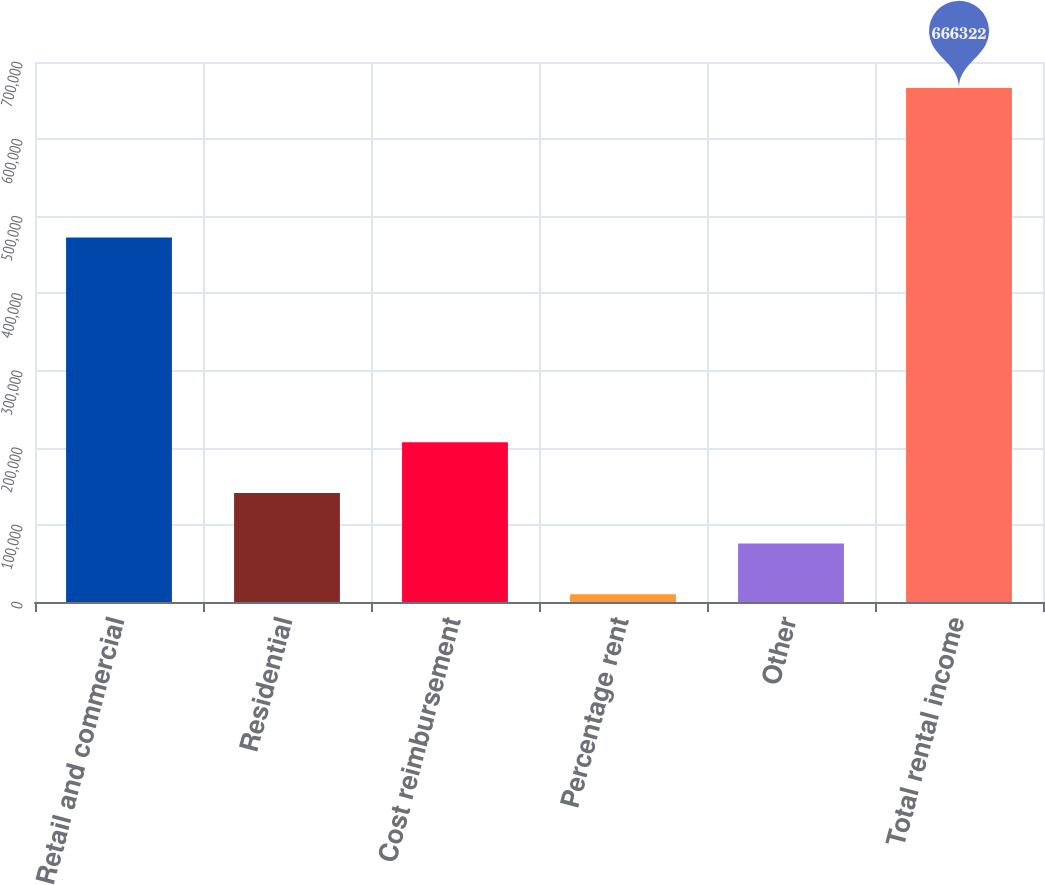Convert chart to OTSL. <chart><loc_0><loc_0><loc_500><loc_500><bar_chart><fcel>Retail and commercial<fcel>Residential<fcel>Cost reimbursement<fcel>Percentage rent<fcel>Other<fcel>Total rental income<nl><fcel>472602<fcel>141400<fcel>207015<fcel>10169<fcel>75784.3<fcel>666322<nl></chart> 